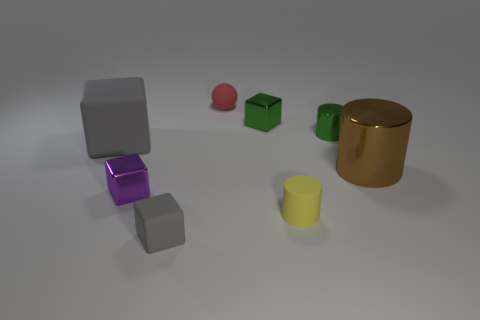Add 1 tiny brown metallic cubes. How many objects exist? 9 Subtract all green spheres. How many gray blocks are left? 2 Subtract all purple blocks. How many blocks are left? 3 Subtract all tiny green metallic cylinders. How many cylinders are left? 2 Subtract 1 cylinders. How many cylinders are left? 2 Subtract all blue blocks. Subtract all green cylinders. How many blocks are left? 4 Subtract all spheres. How many objects are left? 7 Subtract all small cyan shiny things. Subtract all yellow things. How many objects are left? 7 Add 1 green shiny cylinders. How many green shiny cylinders are left? 2 Add 5 purple metal blocks. How many purple metal blocks exist? 6 